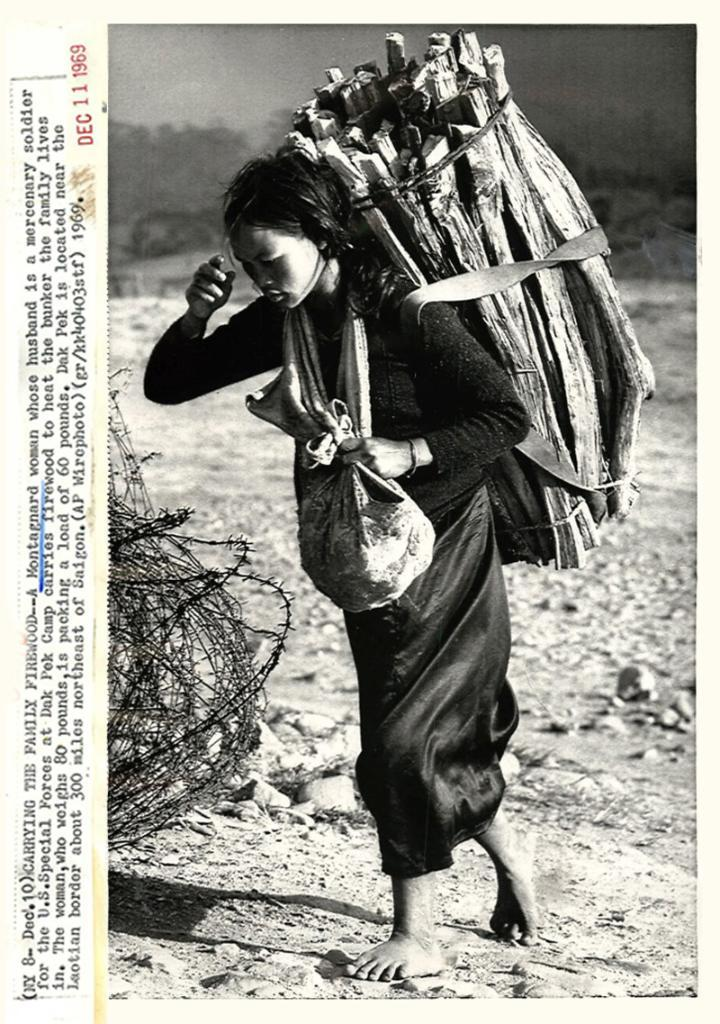Who is the main subject in the image? There is a woman in the image. What is the woman wearing? The woman is wearing a black dress. What is the woman holding in the image? The woman is holding a bag. What is unique about the woman's appearance? The woman has wooden sticks on her back. What can be seen in the background of the image? There are trees in the background of the image. How many children are playing with the zipper in the image? There are no children or zippers present in the image. What force is being applied to the woman in the image? There is no force being applied to the woman in the image; she is standing with wooden sticks on her back. 